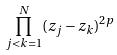Convert formula to latex. <formula><loc_0><loc_0><loc_500><loc_500>\prod _ { j < k = 1 } ^ { N } ( z _ { j } - z _ { k } ) ^ { 2 p }</formula> 